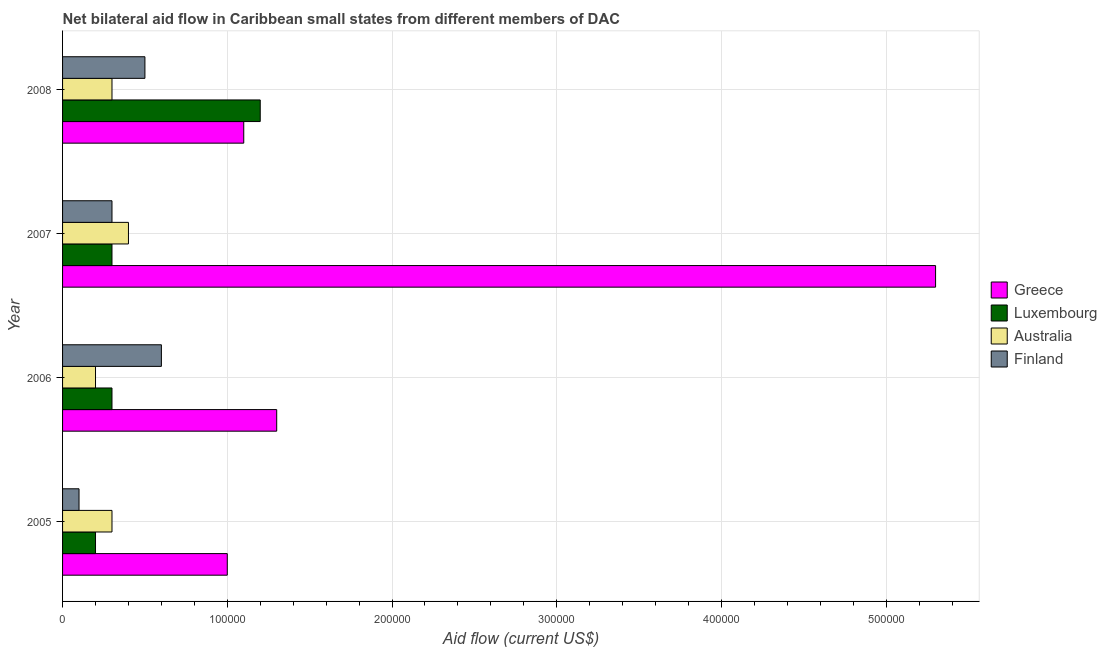How many groups of bars are there?
Provide a succinct answer. 4. How many bars are there on the 1st tick from the bottom?
Keep it short and to the point. 4. In how many cases, is the number of bars for a given year not equal to the number of legend labels?
Your answer should be compact. 0. What is the amount of aid given by finland in 2006?
Your response must be concise. 6.00e+04. Across all years, what is the maximum amount of aid given by finland?
Ensure brevity in your answer.  6.00e+04. Across all years, what is the minimum amount of aid given by finland?
Ensure brevity in your answer.  10000. In which year was the amount of aid given by greece maximum?
Give a very brief answer. 2007. What is the total amount of aid given by luxembourg in the graph?
Provide a short and direct response. 2.00e+05. What is the difference between the amount of aid given by luxembourg in 2006 and that in 2007?
Make the answer very short. 0. What is the difference between the amount of aid given by greece in 2005 and the amount of aid given by australia in 2007?
Offer a terse response. 6.00e+04. What is the average amount of aid given by luxembourg per year?
Ensure brevity in your answer.  5.00e+04. In the year 2005, what is the difference between the amount of aid given by australia and amount of aid given by greece?
Keep it short and to the point. -7.00e+04. What is the ratio of the amount of aid given by luxembourg in 2007 to that in 2008?
Keep it short and to the point. 0.25. Is the difference between the amount of aid given by greece in 2005 and 2008 greater than the difference between the amount of aid given by australia in 2005 and 2008?
Keep it short and to the point. No. What is the difference between the highest and the second highest amount of aid given by australia?
Offer a very short reply. 10000. What is the difference between the highest and the lowest amount of aid given by finland?
Your answer should be compact. 5.00e+04. In how many years, is the amount of aid given by australia greater than the average amount of aid given by australia taken over all years?
Provide a succinct answer. 1. What does the 3rd bar from the bottom in 2008 represents?
Provide a succinct answer. Australia. Are all the bars in the graph horizontal?
Provide a short and direct response. Yes. What is the difference between two consecutive major ticks on the X-axis?
Provide a short and direct response. 1.00e+05. Does the graph contain grids?
Ensure brevity in your answer.  Yes. What is the title of the graph?
Provide a short and direct response. Net bilateral aid flow in Caribbean small states from different members of DAC. Does "Taxes on exports" appear as one of the legend labels in the graph?
Make the answer very short. No. What is the label or title of the X-axis?
Your response must be concise. Aid flow (current US$). What is the label or title of the Y-axis?
Keep it short and to the point. Year. What is the Aid flow (current US$) of Finland in 2005?
Provide a succinct answer. 10000. What is the Aid flow (current US$) of Greece in 2006?
Your answer should be very brief. 1.30e+05. What is the Aid flow (current US$) in Luxembourg in 2006?
Your answer should be compact. 3.00e+04. What is the Aid flow (current US$) in Australia in 2006?
Make the answer very short. 2.00e+04. What is the Aid flow (current US$) in Greece in 2007?
Your answer should be compact. 5.30e+05. What is the Aid flow (current US$) of Finland in 2008?
Offer a very short reply. 5.00e+04. Across all years, what is the maximum Aid flow (current US$) of Greece?
Give a very brief answer. 5.30e+05. Across all years, what is the maximum Aid flow (current US$) of Australia?
Your answer should be very brief. 4.00e+04. Across all years, what is the maximum Aid flow (current US$) in Finland?
Your answer should be very brief. 6.00e+04. Across all years, what is the minimum Aid flow (current US$) of Greece?
Your response must be concise. 1.00e+05. Across all years, what is the minimum Aid flow (current US$) of Luxembourg?
Keep it short and to the point. 2.00e+04. What is the total Aid flow (current US$) in Greece in the graph?
Provide a short and direct response. 8.70e+05. What is the total Aid flow (current US$) of Luxembourg in the graph?
Ensure brevity in your answer.  2.00e+05. What is the difference between the Aid flow (current US$) of Finland in 2005 and that in 2006?
Your answer should be very brief. -5.00e+04. What is the difference between the Aid flow (current US$) in Greece in 2005 and that in 2007?
Your answer should be very brief. -4.30e+05. What is the difference between the Aid flow (current US$) of Luxembourg in 2005 and that in 2007?
Offer a terse response. -10000. What is the difference between the Aid flow (current US$) in Finland in 2005 and that in 2007?
Provide a succinct answer. -2.00e+04. What is the difference between the Aid flow (current US$) in Luxembourg in 2005 and that in 2008?
Your answer should be compact. -1.00e+05. What is the difference between the Aid flow (current US$) of Greece in 2006 and that in 2007?
Ensure brevity in your answer.  -4.00e+05. What is the difference between the Aid flow (current US$) of Luxembourg in 2006 and that in 2007?
Your answer should be compact. 0. What is the difference between the Aid flow (current US$) of Australia in 2006 and that in 2007?
Provide a short and direct response. -2.00e+04. What is the difference between the Aid flow (current US$) in Finland in 2006 and that in 2007?
Give a very brief answer. 3.00e+04. What is the difference between the Aid flow (current US$) in Greece in 2006 and that in 2008?
Your answer should be very brief. 2.00e+04. What is the difference between the Aid flow (current US$) of Luxembourg in 2006 and that in 2008?
Keep it short and to the point. -9.00e+04. What is the difference between the Aid flow (current US$) of Australia in 2006 and that in 2008?
Your response must be concise. -10000. What is the difference between the Aid flow (current US$) in Greece in 2007 and that in 2008?
Give a very brief answer. 4.20e+05. What is the difference between the Aid flow (current US$) of Greece in 2005 and the Aid flow (current US$) of Luxembourg in 2006?
Ensure brevity in your answer.  7.00e+04. What is the difference between the Aid flow (current US$) of Greece in 2005 and the Aid flow (current US$) of Finland in 2006?
Provide a short and direct response. 4.00e+04. What is the difference between the Aid flow (current US$) in Luxembourg in 2005 and the Aid flow (current US$) in Australia in 2006?
Give a very brief answer. 0. What is the difference between the Aid flow (current US$) in Australia in 2005 and the Aid flow (current US$) in Finland in 2006?
Ensure brevity in your answer.  -3.00e+04. What is the difference between the Aid flow (current US$) in Greece in 2005 and the Aid flow (current US$) in Finland in 2007?
Provide a short and direct response. 7.00e+04. What is the difference between the Aid flow (current US$) in Luxembourg in 2005 and the Aid flow (current US$) in Finland in 2007?
Give a very brief answer. -10000. What is the difference between the Aid flow (current US$) of Greece in 2005 and the Aid flow (current US$) of Australia in 2008?
Give a very brief answer. 7.00e+04. What is the difference between the Aid flow (current US$) of Greece in 2005 and the Aid flow (current US$) of Finland in 2008?
Offer a very short reply. 5.00e+04. What is the difference between the Aid flow (current US$) in Luxembourg in 2005 and the Aid flow (current US$) in Finland in 2008?
Provide a short and direct response. -3.00e+04. What is the difference between the Aid flow (current US$) of Luxembourg in 2006 and the Aid flow (current US$) of Australia in 2007?
Offer a very short reply. -10000. What is the difference between the Aid flow (current US$) in Luxembourg in 2006 and the Aid flow (current US$) in Finland in 2007?
Your answer should be very brief. 0. What is the difference between the Aid flow (current US$) in Australia in 2006 and the Aid flow (current US$) in Finland in 2007?
Keep it short and to the point. -10000. What is the difference between the Aid flow (current US$) in Greece in 2006 and the Aid flow (current US$) in Finland in 2008?
Your answer should be very brief. 8.00e+04. What is the difference between the Aid flow (current US$) of Greece in 2007 and the Aid flow (current US$) of Luxembourg in 2008?
Offer a terse response. 4.10e+05. What is the difference between the Aid flow (current US$) of Luxembourg in 2007 and the Aid flow (current US$) of Australia in 2008?
Make the answer very short. 0. What is the difference between the Aid flow (current US$) of Luxembourg in 2007 and the Aid flow (current US$) of Finland in 2008?
Offer a terse response. -2.00e+04. What is the difference between the Aid flow (current US$) in Australia in 2007 and the Aid flow (current US$) in Finland in 2008?
Provide a succinct answer. -10000. What is the average Aid flow (current US$) in Greece per year?
Make the answer very short. 2.18e+05. What is the average Aid flow (current US$) in Australia per year?
Your answer should be compact. 3.00e+04. What is the average Aid flow (current US$) in Finland per year?
Offer a very short reply. 3.75e+04. In the year 2005, what is the difference between the Aid flow (current US$) of Greece and Aid flow (current US$) of Australia?
Provide a short and direct response. 7.00e+04. In the year 2005, what is the difference between the Aid flow (current US$) of Greece and Aid flow (current US$) of Finland?
Offer a terse response. 9.00e+04. In the year 2005, what is the difference between the Aid flow (current US$) in Luxembourg and Aid flow (current US$) in Finland?
Keep it short and to the point. 10000. In the year 2006, what is the difference between the Aid flow (current US$) of Greece and Aid flow (current US$) of Finland?
Your answer should be very brief. 7.00e+04. In the year 2006, what is the difference between the Aid flow (current US$) of Australia and Aid flow (current US$) of Finland?
Ensure brevity in your answer.  -4.00e+04. In the year 2007, what is the difference between the Aid flow (current US$) of Greece and Aid flow (current US$) of Australia?
Provide a succinct answer. 4.90e+05. In the year 2007, what is the difference between the Aid flow (current US$) in Luxembourg and Aid flow (current US$) in Finland?
Ensure brevity in your answer.  0. In the year 2008, what is the difference between the Aid flow (current US$) of Greece and Aid flow (current US$) of Australia?
Ensure brevity in your answer.  8.00e+04. In the year 2008, what is the difference between the Aid flow (current US$) in Greece and Aid flow (current US$) in Finland?
Give a very brief answer. 6.00e+04. In the year 2008, what is the difference between the Aid flow (current US$) of Luxembourg and Aid flow (current US$) of Australia?
Provide a short and direct response. 9.00e+04. In the year 2008, what is the difference between the Aid flow (current US$) in Luxembourg and Aid flow (current US$) in Finland?
Provide a short and direct response. 7.00e+04. In the year 2008, what is the difference between the Aid flow (current US$) in Australia and Aid flow (current US$) in Finland?
Keep it short and to the point. -2.00e+04. What is the ratio of the Aid flow (current US$) in Greece in 2005 to that in 2006?
Ensure brevity in your answer.  0.77. What is the ratio of the Aid flow (current US$) in Luxembourg in 2005 to that in 2006?
Ensure brevity in your answer.  0.67. What is the ratio of the Aid flow (current US$) in Australia in 2005 to that in 2006?
Provide a succinct answer. 1.5. What is the ratio of the Aid flow (current US$) in Greece in 2005 to that in 2007?
Ensure brevity in your answer.  0.19. What is the ratio of the Aid flow (current US$) in Australia in 2005 to that in 2007?
Give a very brief answer. 0.75. What is the ratio of the Aid flow (current US$) in Finland in 2005 to that in 2007?
Your response must be concise. 0.33. What is the ratio of the Aid flow (current US$) of Greece in 2005 to that in 2008?
Offer a terse response. 0.91. What is the ratio of the Aid flow (current US$) of Finland in 2005 to that in 2008?
Your answer should be compact. 0.2. What is the ratio of the Aid flow (current US$) in Greece in 2006 to that in 2007?
Make the answer very short. 0.25. What is the ratio of the Aid flow (current US$) in Greece in 2006 to that in 2008?
Provide a short and direct response. 1.18. What is the ratio of the Aid flow (current US$) of Luxembourg in 2006 to that in 2008?
Your answer should be compact. 0.25. What is the ratio of the Aid flow (current US$) of Greece in 2007 to that in 2008?
Your answer should be compact. 4.82. What is the ratio of the Aid flow (current US$) of Luxembourg in 2007 to that in 2008?
Ensure brevity in your answer.  0.25. What is the difference between the highest and the second highest Aid flow (current US$) of Greece?
Offer a terse response. 4.00e+05. What is the difference between the highest and the second highest Aid flow (current US$) of Luxembourg?
Offer a terse response. 9.00e+04. What is the difference between the highest and the second highest Aid flow (current US$) in Finland?
Offer a very short reply. 10000. What is the difference between the highest and the lowest Aid flow (current US$) in Luxembourg?
Offer a terse response. 1.00e+05. What is the difference between the highest and the lowest Aid flow (current US$) of Australia?
Provide a succinct answer. 2.00e+04. 